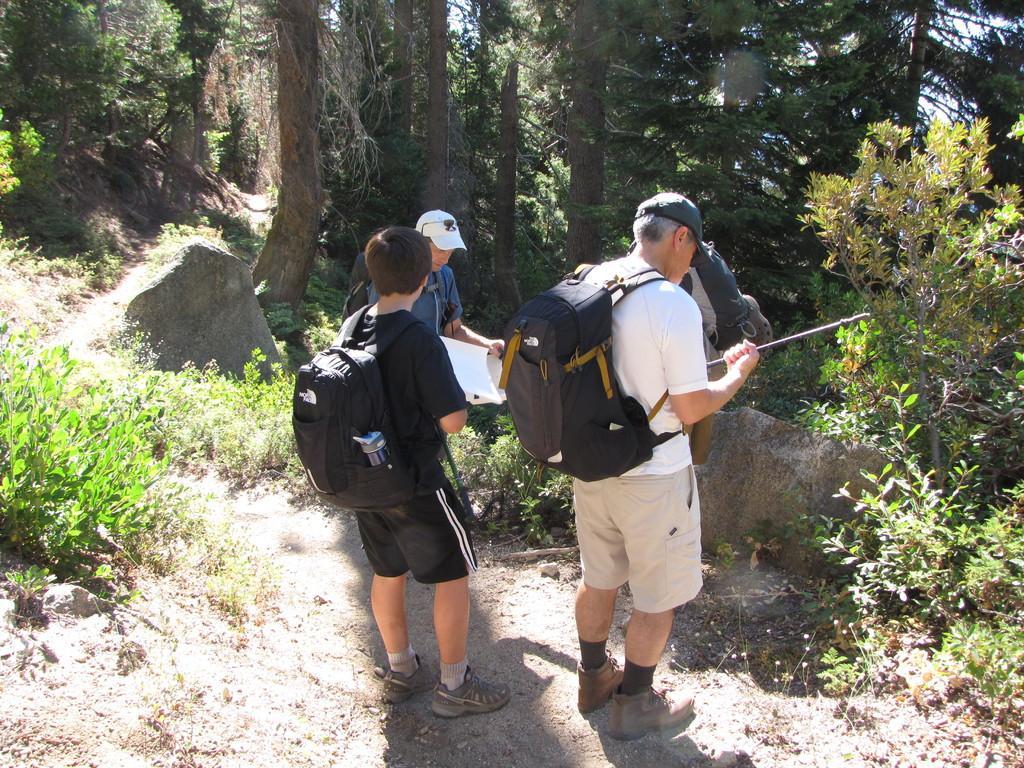How would you summarize this image in a sentence or two? In this image I can see the group of people with bags. I can see two people with caps, one person holding the stick and an another person holding the paper. On both sides of these people I can see the plants. In the background I can see the rock's, many trees and the sky. 